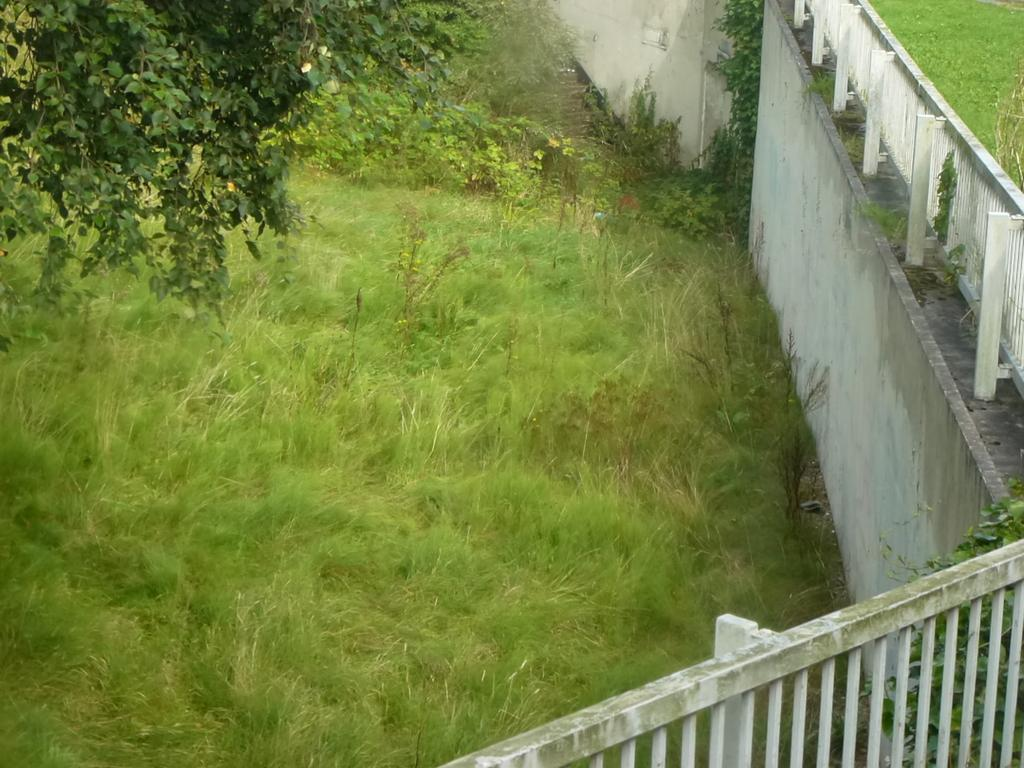What type of vegetation is present on the ground in the image? There is grass on the ground in the image. What other types of vegetation can be seen in the image? There are plants in the image. What part of a tree can be seen in the image? Branches of a tree are visible in the image. What structures are present in the image? There is a wall and a fence in the image. What advice is the grass giving to the plants in the image? The grass does not give advice to the plants in the image, as plants and grass do not communicate in this manner. 